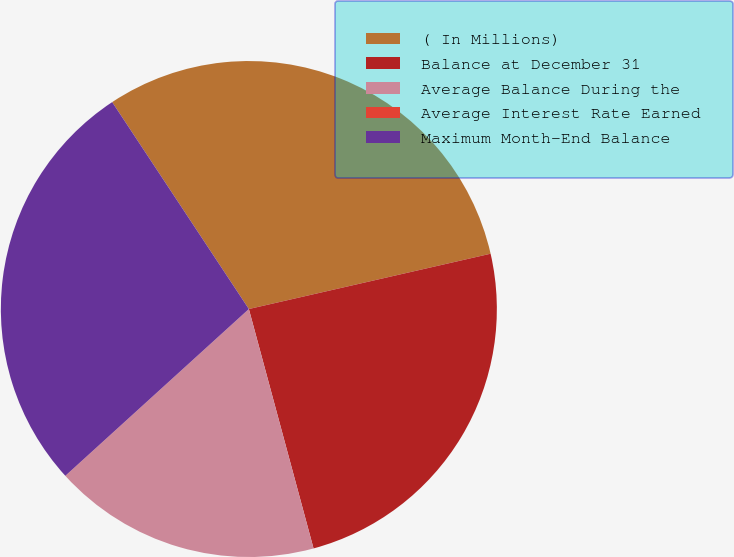<chart> <loc_0><loc_0><loc_500><loc_500><pie_chart><fcel>( In Millions)<fcel>Balance at December 31<fcel>Average Balance During the<fcel>Average Interest Rate Earned<fcel>Maximum Month-End Balance<nl><fcel>30.71%<fcel>24.38%<fcel>17.45%<fcel>0.01%<fcel>27.45%<nl></chart> 